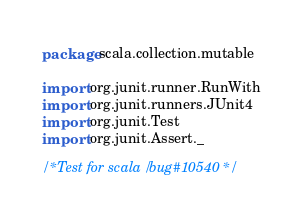<code> <loc_0><loc_0><loc_500><loc_500><_Scala_>package scala.collection.mutable

import org.junit.runner.RunWith
import org.junit.runners.JUnit4
import org.junit.Test
import org.junit.Assert._

/* Test for scala/bug#10540 */</code> 